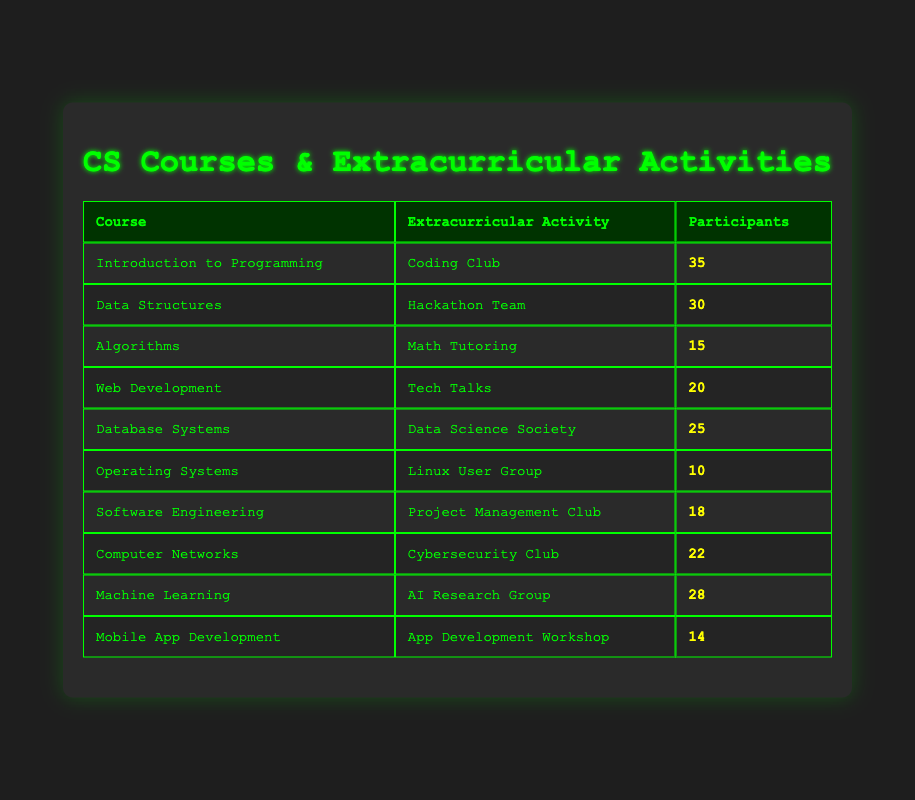What is the maximum number of participants in a single extracurricular activity? By reviewing the "participants" column, the highest value is 35 from the "Coding Club" associated with the "Introduction to Programming" course.
Answer: 35 Which extracurricular activity has the least number of participants? Checking the participants for each activity, the "Linux User Group" under "Operating Systems" has the lowest count of 10 participants.
Answer: Linux User Group How many participants are involved in both the "Coding Club" and "Hackathon Team"? Summing the participants from those two activities, we have 35 (Coding Club) + 30 (Hackathon Team) = 65 participants total.
Answer: 65 Are there more participants in "Machine Learning" than in "Algorithms"? Comparing the two values: "Machine Learning" has 28 participants, while "Algorithms" has 15. Therefore, there are more participants in Machine Learning.
Answer: Yes What is the average number of participants across all extracurricular activities listed? To find the average, sum the participants (35 + 30 + 15 + 20 + 25 + 10 + 18 + 22 + 28 + 14) =  35 + 30 + 15 + 20 + 25 + 10 + 18 + 22 + 28 + 14 =  217. Then divide by the number of activities (10), giving an average of 217/10 = 21.7.
Answer: 21.7 Which course has the highest number of participants in its related extracurricular activity? The highest number of participants is from the "Introduction to Programming" course, with the "Coding Club" having 35 participants.
Answer: Introduction to Programming Is there any extracurricular activity that has exactly 20 participants? Referring to the table, "Tech Talks" under "Web Development" has exactly 20 participants.
Answer: Yes How many more participants are in "Data Structures" compared to "Operating Systems"? Subtracting the participants: 30 (Data Structures) - 10 (Operating Systems) = 20 more participants in Data Structures.
Answer: 20 